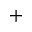Convert formula to latex. <formula><loc_0><loc_0><loc_500><loc_500>^ { + }</formula> 